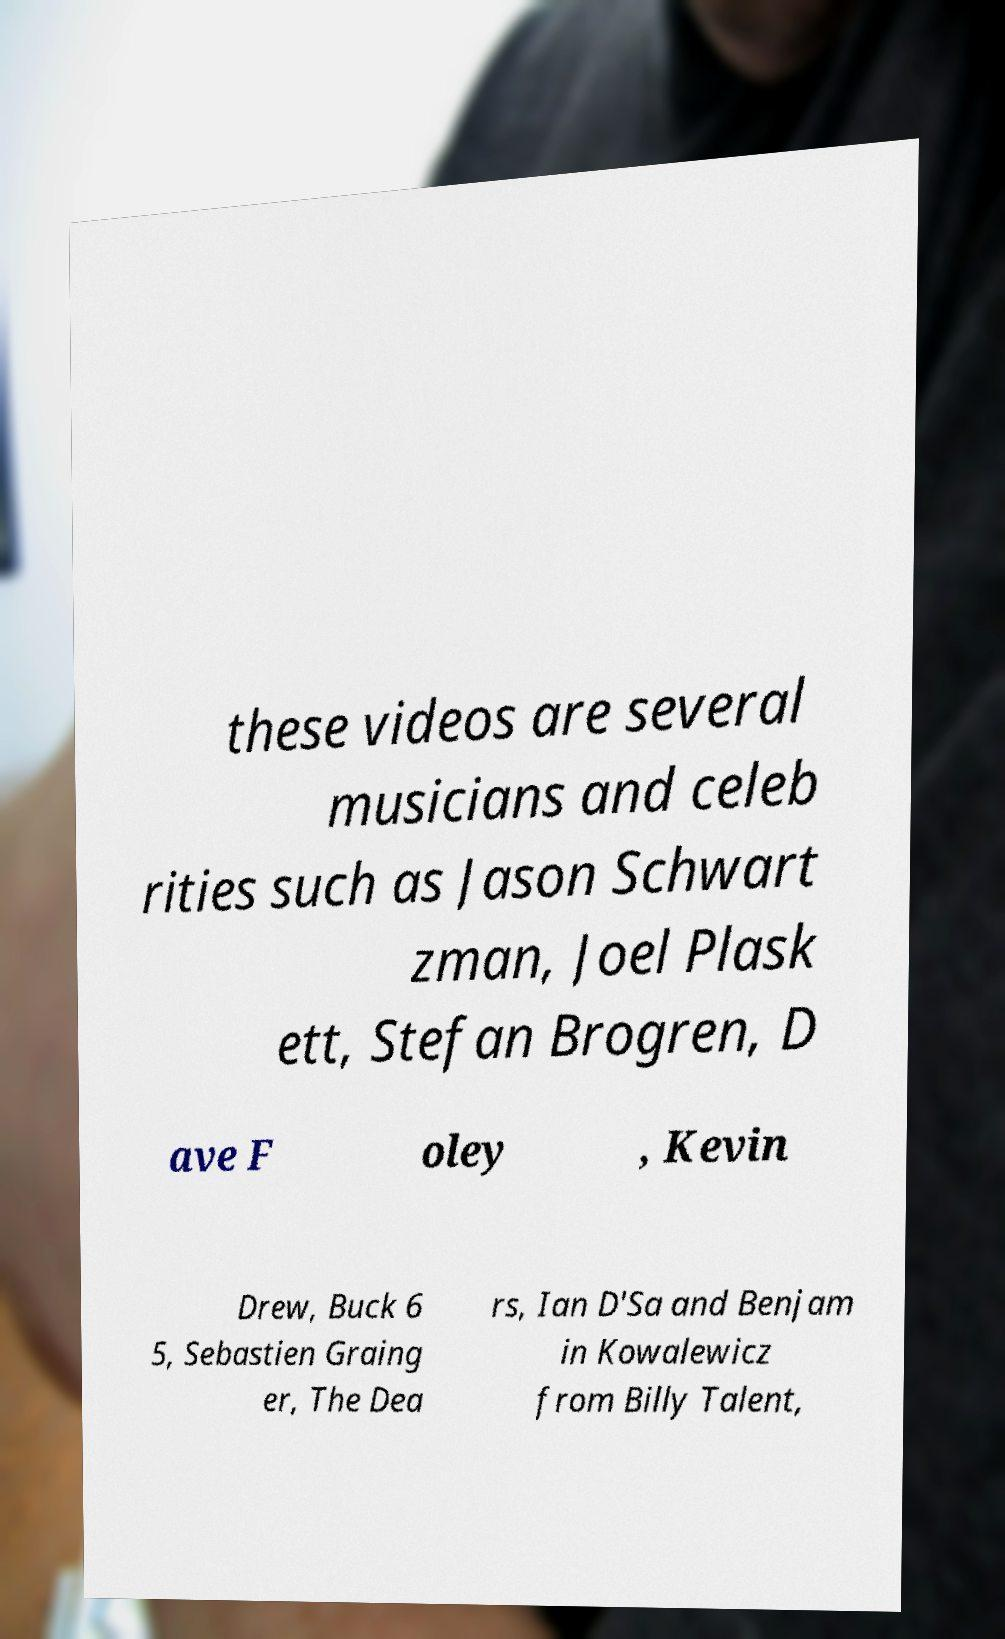Could you extract and type out the text from this image? these videos are several musicians and celeb rities such as Jason Schwart zman, Joel Plask ett, Stefan Brogren, D ave F oley , Kevin Drew, Buck 6 5, Sebastien Graing er, The Dea rs, Ian D'Sa and Benjam in Kowalewicz from Billy Talent, 